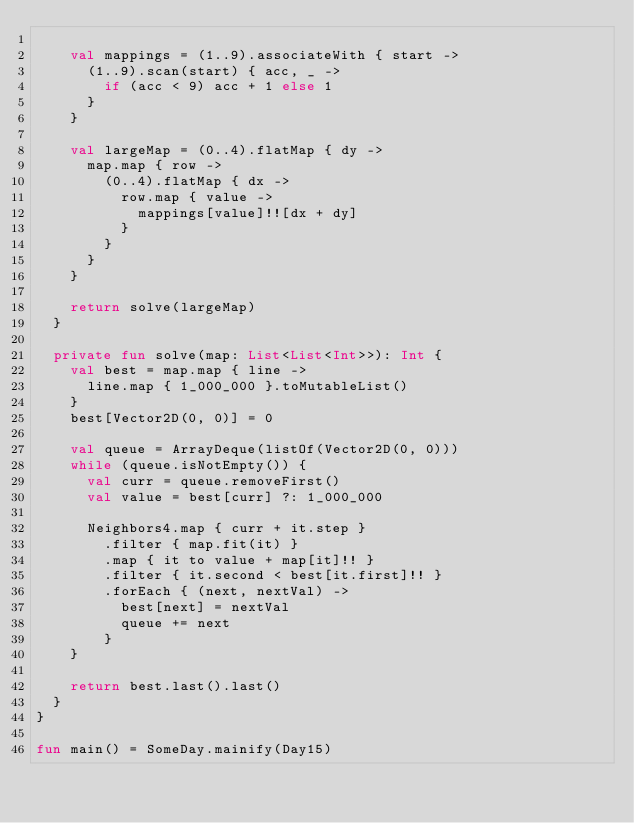<code> <loc_0><loc_0><loc_500><loc_500><_Kotlin_>
    val mappings = (1..9).associateWith { start ->
      (1..9).scan(start) { acc, _ ->
        if (acc < 9) acc + 1 else 1
      }
    }

    val largeMap = (0..4).flatMap { dy ->
      map.map { row ->
        (0..4).flatMap { dx ->
          row.map { value ->
            mappings[value]!![dx + dy]
          }
        }
      }
    }

    return solve(largeMap)
  }

  private fun solve(map: List<List<Int>>): Int {
    val best = map.map { line ->
      line.map { 1_000_000 }.toMutableList()
    }
    best[Vector2D(0, 0)] = 0

    val queue = ArrayDeque(listOf(Vector2D(0, 0)))
    while (queue.isNotEmpty()) {
      val curr = queue.removeFirst()
      val value = best[curr] ?: 1_000_000

      Neighbors4.map { curr + it.step }
        .filter { map.fit(it) }
        .map { it to value + map[it]!! }
        .filter { it.second < best[it.first]!! }
        .forEach { (next, nextVal) ->
          best[next] = nextVal
          queue += next
        }
    }

    return best.last().last()
  }
}

fun main() = SomeDay.mainify(Day15)
</code> 